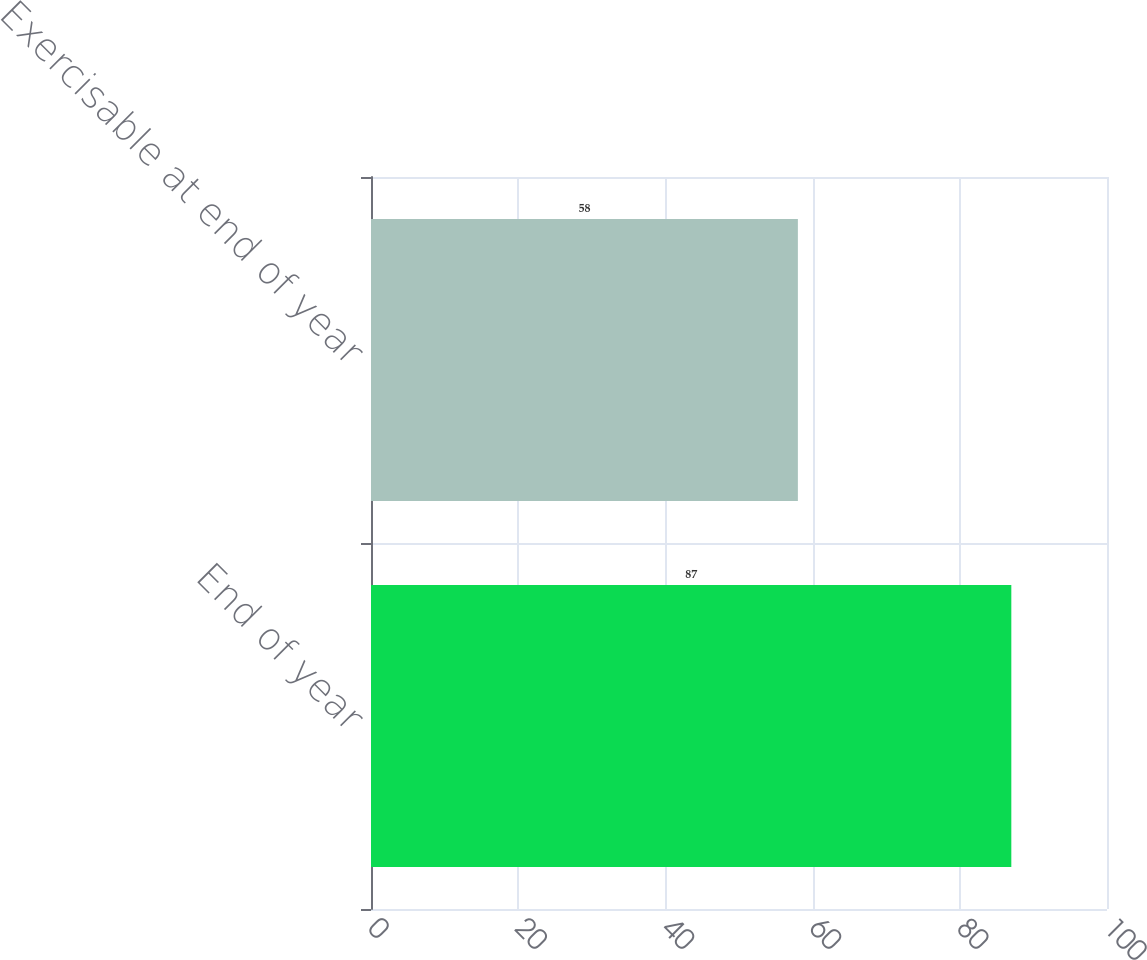Convert chart. <chart><loc_0><loc_0><loc_500><loc_500><bar_chart><fcel>End of year<fcel>Exercisable at end of year<nl><fcel>87<fcel>58<nl></chart> 